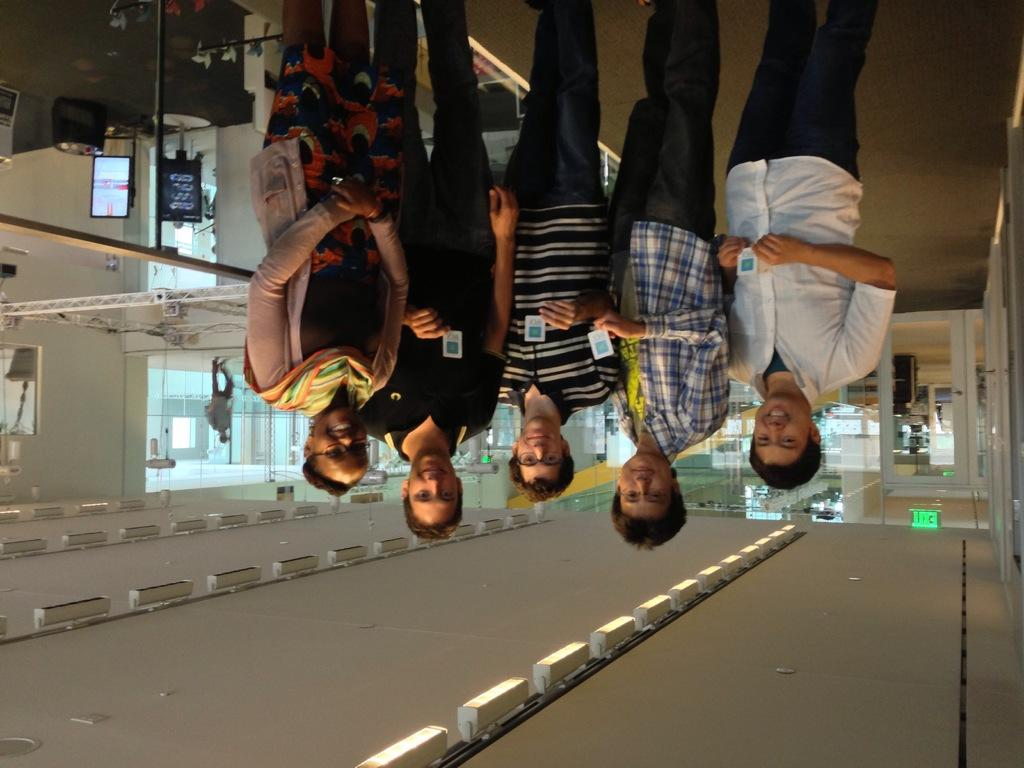What are the people in the center of the image doing? There are people standing in the center of the image. What can be seen in the background of the image? There are doors and a man walking in the background of the image. What is located at the bottom of the image? There are lights and some equipment visible at the bottom of the image. What is the man in the background learning in the image? There is no indication in the image that the man in the background is learning anything. 